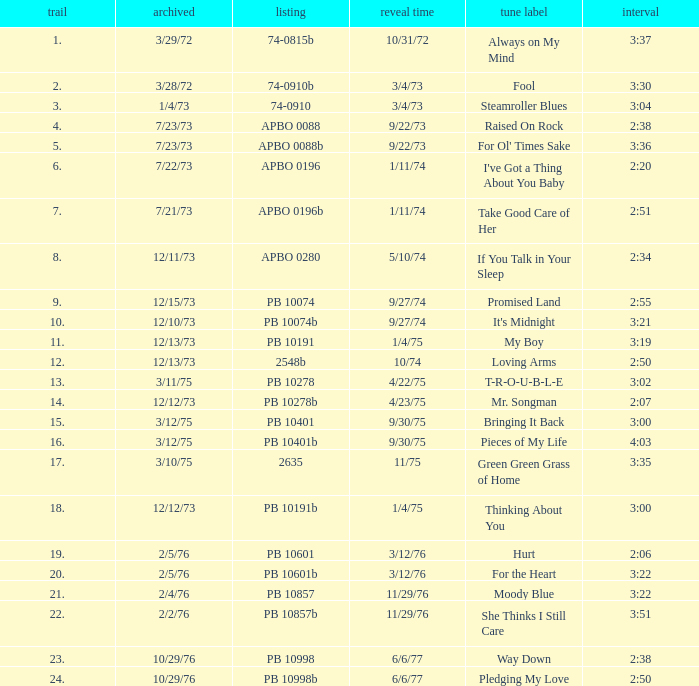Name the catalogue that has tracks less than 13 and the release date of 10/31/72 74-0815b. 